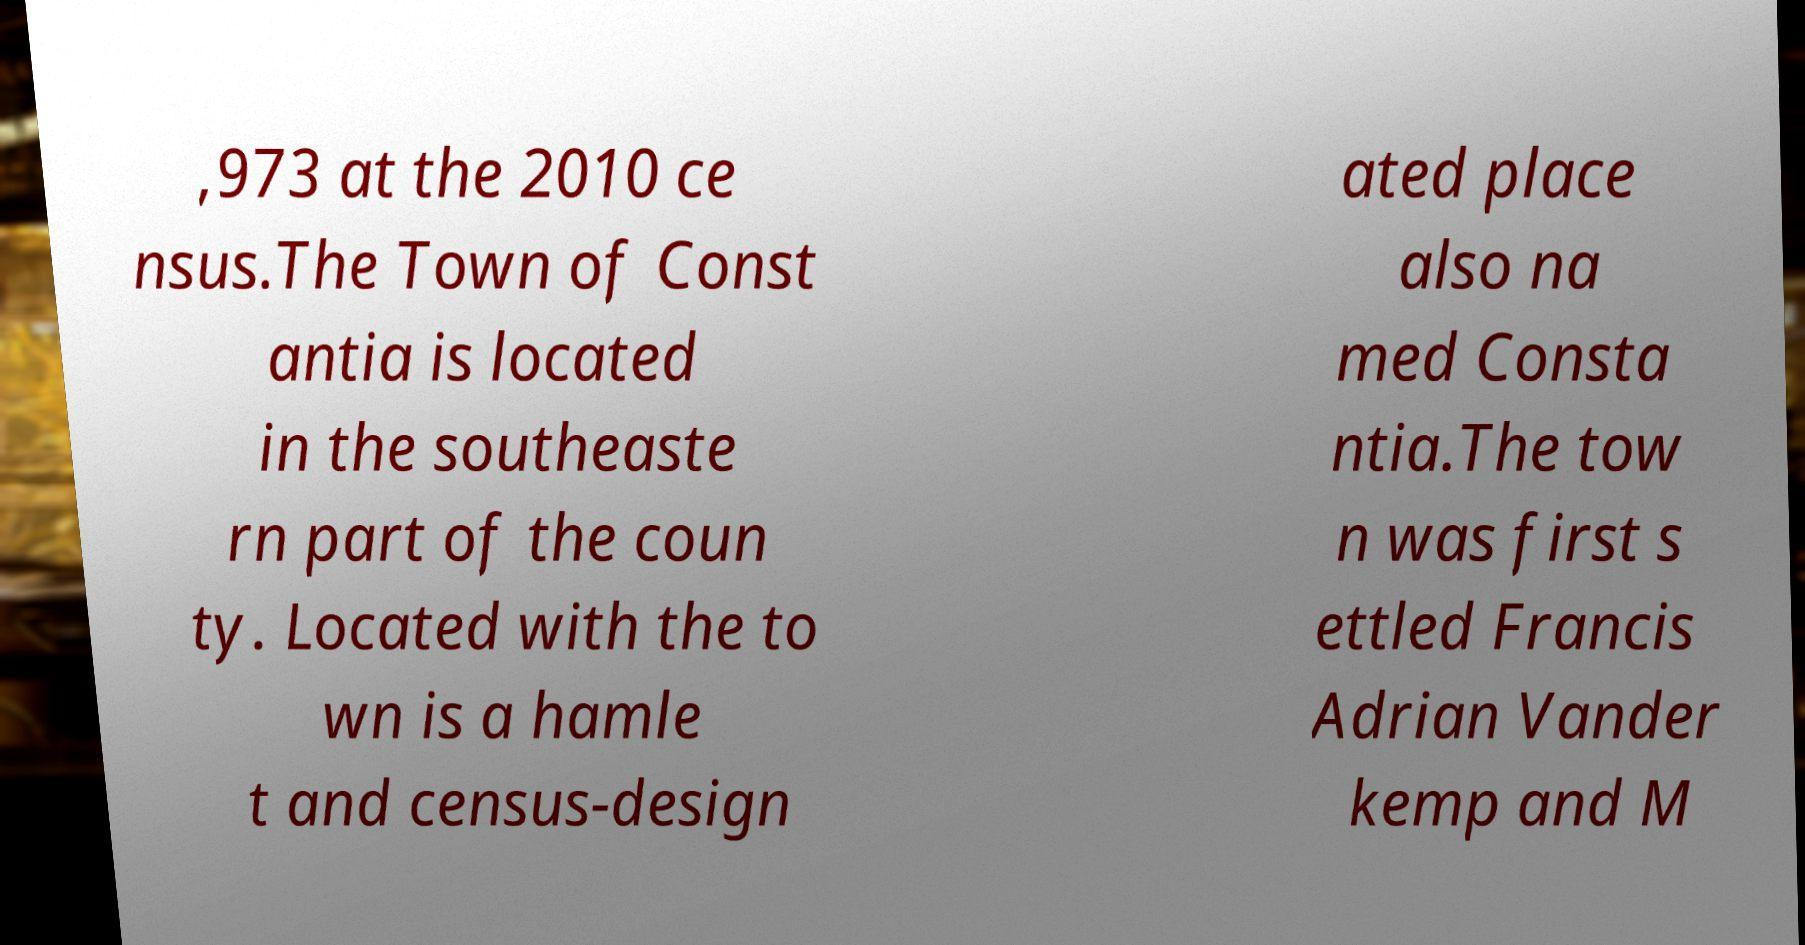Can you accurately transcribe the text from the provided image for me? ,973 at the 2010 ce nsus.The Town of Const antia is located in the southeaste rn part of the coun ty. Located with the to wn is a hamle t and census-design ated place also na med Consta ntia.The tow n was first s ettled Francis Adrian Vander kemp and M 